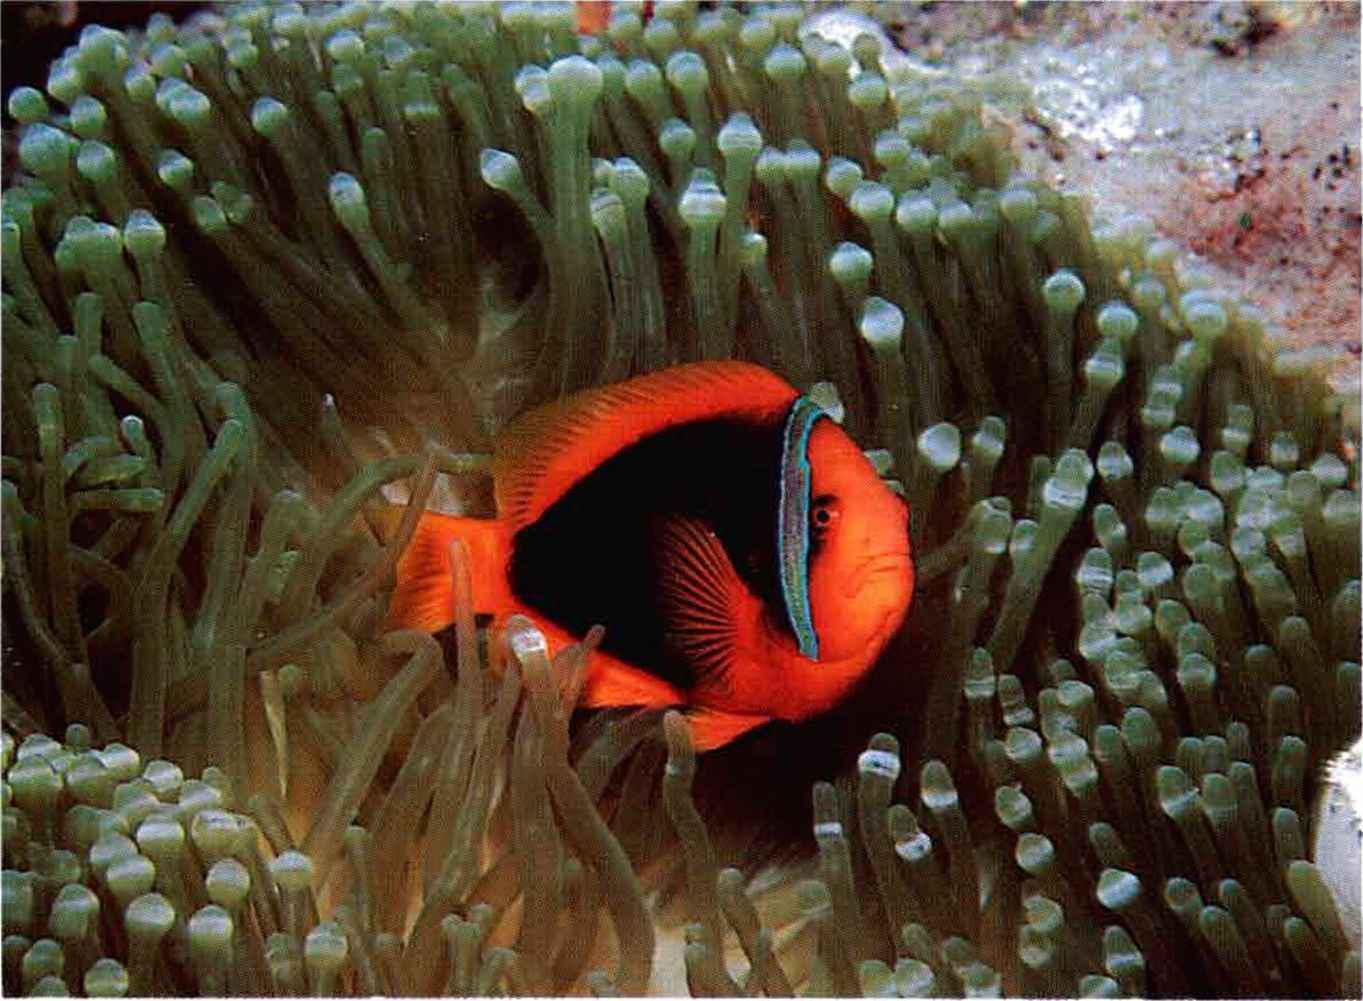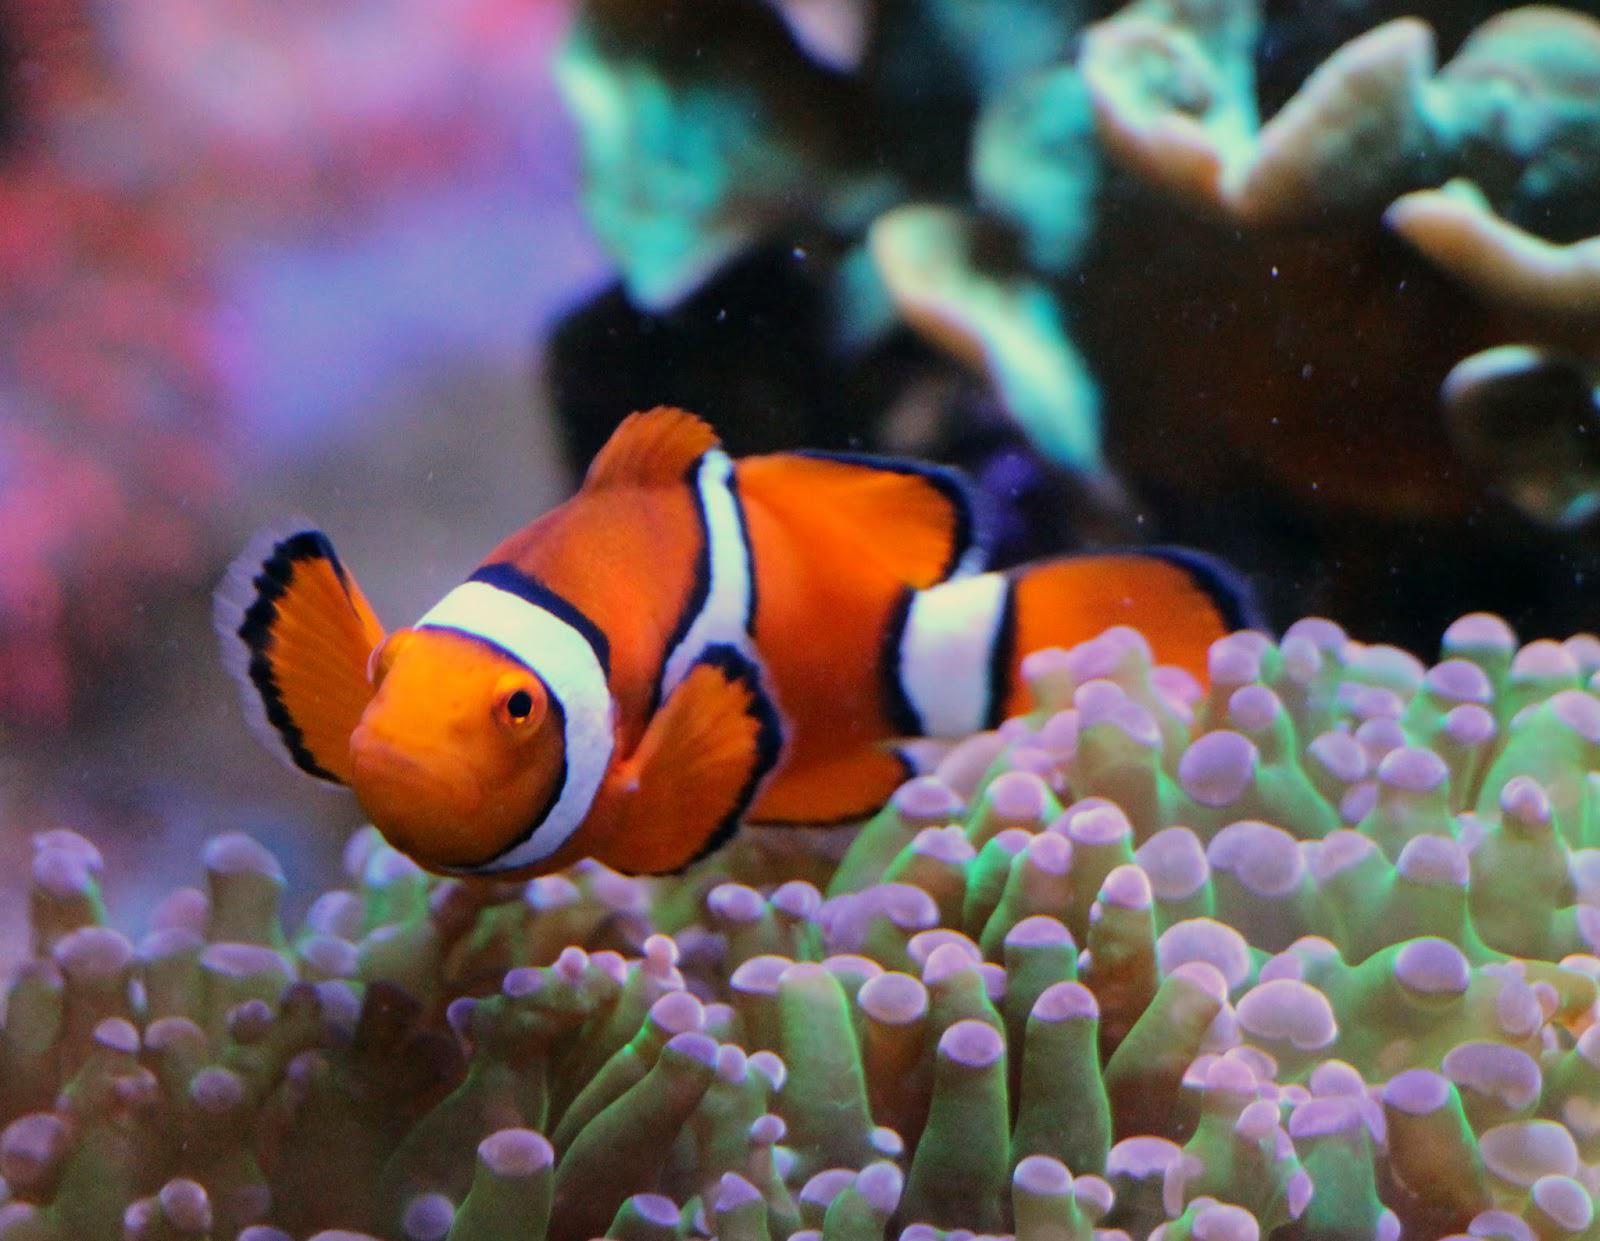The first image is the image on the left, the second image is the image on the right. Given the left and right images, does the statement "There are at most three clownfish swimming." hold true? Answer yes or no. Yes. The first image is the image on the left, the second image is the image on the right. For the images shown, is this caption "At least three orange and white fish swim in the water." true? Answer yes or no. No. 